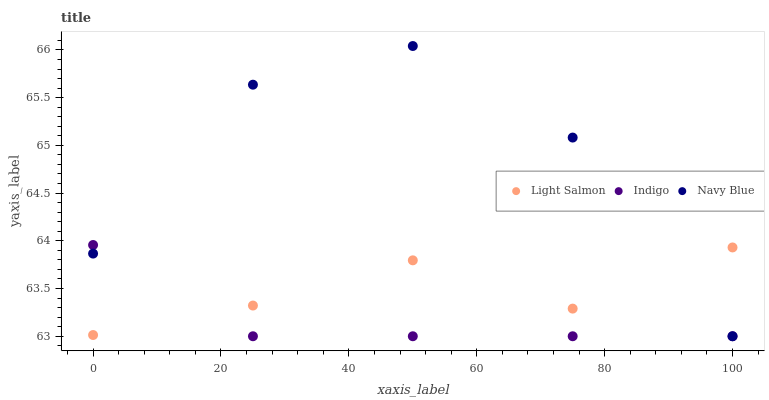Does Indigo have the minimum area under the curve?
Answer yes or no. Yes. Does Navy Blue have the maximum area under the curve?
Answer yes or no. Yes. Does Light Salmon have the minimum area under the curve?
Answer yes or no. No. Does Light Salmon have the maximum area under the curve?
Answer yes or no. No. Is Indigo the smoothest?
Answer yes or no. Yes. Is Navy Blue the roughest?
Answer yes or no. Yes. Is Light Salmon the smoothest?
Answer yes or no. No. Is Light Salmon the roughest?
Answer yes or no. No. Does Navy Blue have the lowest value?
Answer yes or no. Yes. Does Light Salmon have the lowest value?
Answer yes or no. No. Does Navy Blue have the highest value?
Answer yes or no. Yes. Does Indigo have the highest value?
Answer yes or no. No. Does Light Salmon intersect Navy Blue?
Answer yes or no. Yes. Is Light Salmon less than Navy Blue?
Answer yes or no. No. Is Light Salmon greater than Navy Blue?
Answer yes or no. No. 